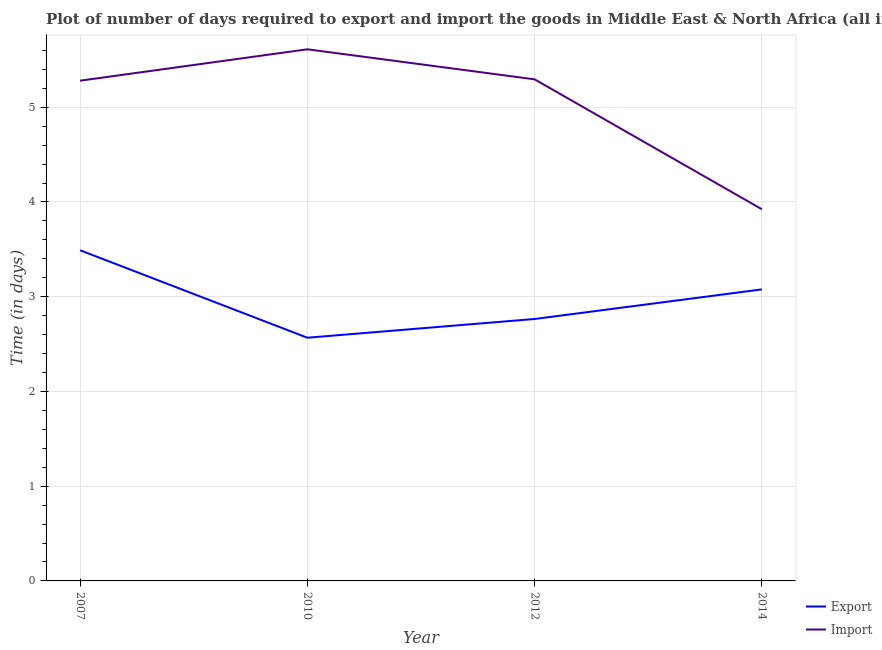How many different coloured lines are there?
Give a very brief answer. 2. Does the line corresponding to time required to export intersect with the line corresponding to time required to import?
Provide a short and direct response. No. Is the number of lines equal to the number of legend labels?
Provide a short and direct response. Yes. What is the time required to export in 2014?
Keep it short and to the point. 3.08. Across all years, what is the maximum time required to export?
Keep it short and to the point. 3.49. Across all years, what is the minimum time required to export?
Your answer should be very brief. 2.57. In which year was the time required to import minimum?
Give a very brief answer. 2014. What is the total time required to import in the graph?
Provide a succinct answer. 20.11. What is the difference between the time required to export in 2010 and that in 2012?
Offer a terse response. -0.2. What is the difference between the time required to import in 2010 and the time required to export in 2007?
Offer a very short reply. 2.12. What is the average time required to import per year?
Ensure brevity in your answer.  5.03. In the year 2014, what is the difference between the time required to export and time required to import?
Offer a very short reply. -0.85. What is the ratio of the time required to import in 2012 to that in 2014?
Give a very brief answer. 1.35. Is the time required to export in 2012 less than that in 2014?
Provide a succinct answer. Yes. What is the difference between the highest and the second highest time required to import?
Offer a terse response. 0.32. What is the difference between the highest and the lowest time required to export?
Keep it short and to the point. 0.92. Is the sum of the time required to import in 2010 and 2014 greater than the maximum time required to export across all years?
Provide a short and direct response. Yes. Is the time required to export strictly less than the time required to import over the years?
Offer a terse response. Yes. Are the values on the major ticks of Y-axis written in scientific E-notation?
Give a very brief answer. No. Does the graph contain grids?
Provide a short and direct response. Yes. What is the title of the graph?
Your answer should be compact. Plot of number of days required to export and import the goods in Middle East & North Africa (all income levels). Does "Official aid received" appear as one of the legend labels in the graph?
Provide a succinct answer. No. What is the label or title of the Y-axis?
Ensure brevity in your answer.  Time (in days). What is the Time (in days) of Export in 2007?
Provide a short and direct response. 3.49. What is the Time (in days) in Import in 2007?
Give a very brief answer. 5.28. What is the Time (in days) of Export in 2010?
Your response must be concise. 2.57. What is the Time (in days) in Import in 2010?
Keep it short and to the point. 5.61. What is the Time (in days) of Export in 2012?
Make the answer very short. 2.76. What is the Time (in days) in Import in 2012?
Provide a short and direct response. 5.29. What is the Time (in days) of Export in 2014?
Give a very brief answer. 3.08. What is the Time (in days) in Import in 2014?
Offer a terse response. 3.92. Across all years, what is the maximum Time (in days) of Export?
Ensure brevity in your answer.  3.49. Across all years, what is the maximum Time (in days) in Import?
Your answer should be very brief. 5.61. Across all years, what is the minimum Time (in days) in Export?
Offer a terse response. 2.57. Across all years, what is the minimum Time (in days) in Import?
Provide a short and direct response. 3.92. What is the total Time (in days) in Export in the graph?
Provide a short and direct response. 11.9. What is the total Time (in days) of Import in the graph?
Offer a very short reply. 20.11. What is the difference between the Time (in days) of Import in 2007 and that in 2010?
Provide a succinct answer. -0.33. What is the difference between the Time (in days) of Export in 2007 and that in 2012?
Ensure brevity in your answer.  0.73. What is the difference between the Time (in days) of Import in 2007 and that in 2012?
Provide a succinct answer. -0.01. What is the difference between the Time (in days) in Export in 2007 and that in 2014?
Provide a short and direct response. 0.41. What is the difference between the Time (in days) in Import in 2007 and that in 2014?
Keep it short and to the point. 1.36. What is the difference between the Time (in days) in Export in 2010 and that in 2012?
Your response must be concise. -0.2. What is the difference between the Time (in days) in Import in 2010 and that in 2012?
Your answer should be very brief. 0.32. What is the difference between the Time (in days) in Export in 2010 and that in 2014?
Provide a succinct answer. -0.51. What is the difference between the Time (in days) of Import in 2010 and that in 2014?
Your answer should be compact. 1.69. What is the difference between the Time (in days) in Export in 2012 and that in 2014?
Make the answer very short. -0.31. What is the difference between the Time (in days) of Import in 2012 and that in 2014?
Your answer should be very brief. 1.37. What is the difference between the Time (in days) in Export in 2007 and the Time (in days) in Import in 2010?
Offer a terse response. -2.12. What is the difference between the Time (in days) in Export in 2007 and the Time (in days) in Import in 2012?
Provide a succinct answer. -1.8. What is the difference between the Time (in days) in Export in 2007 and the Time (in days) in Import in 2014?
Provide a short and direct response. -0.43. What is the difference between the Time (in days) of Export in 2010 and the Time (in days) of Import in 2012?
Provide a succinct answer. -2.73. What is the difference between the Time (in days) of Export in 2010 and the Time (in days) of Import in 2014?
Your response must be concise. -1.36. What is the difference between the Time (in days) in Export in 2012 and the Time (in days) in Import in 2014?
Offer a terse response. -1.16. What is the average Time (in days) in Export per year?
Keep it short and to the point. 2.97. What is the average Time (in days) in Import per year?
Your answer should be compact. 5.03. In the year 2007, what is the difference between the Time (in days) of Export and Time (in days) of Import?
Your answer should be compact. -1.79. In the year 2010, what is the difference between the Time (in days) of Export and Time (in days) of Import?
Offer a very short reply. -3.04. In the year 2012, what is the difference between the Time (in days) in Export and Time (in days) in Import?
Make the answer very short. -2.53. In the year 2014, what is the difference between the Time (in days) of Export and Time (in days) of Import?
Your answer should be very brief. -0.85. What is the ratio of the Time (in days) in Export in 2007 to that in 2010?
Make the answer very short. 1.36. What is the ratio of the Time (in days) in Import in 2007 to that in 2010?
Provide a short and direct response. 0.94. What is the ratio of the Time (in days) in Export in 2007 to that in 2012?
Your response must be concise. 1.26. What is the ratio of the Time (in days) in Export in 2007 to that in 2014?
Give a very brief answer. 1.13. What is the ratio of the Time (in days) of Import in 2007 to that in 2014?
Provide a succinct answer. 1.35. What is the ratio of the Time (in days) in Export in 2010 to that in 2012?
Provide a succinct answer. 0.93. What is the ratio of the Time (in days) of Import in 2010 to that in 2012?
Make the answer very short. 1.06. What is the ratio of the Time (in days) of Export in 2010 to that in 2014?
Offer a very short reply. 0.83. What is the ratio of the Time (in days) in Import in 2010 to that in 2014?
Offer a very short reply. 1.43. What is the ratio of the Time (in days) of Export in 2012 to that in 2014?
Offer a very short reply. 0.9. What is the ratio of the Time (in days) in Import in 2012 to that in 2014?
Keep it short and to the point. 1.35. What is the difference between the highest and the second highest Time (in days) of Export?
Provide a succinct answer. 0.41. What is the difference between the highest and the second highest Time (in days) in Import?
Ensure brevity in your answer.  0.32. What is the difference between the highest and the lowest Time (in days) of Export?
Give a very brief answer. 0.92. What is the difference between the highest and the lowest Time (in days) of Import?
Make the answer very short. 1.69. 